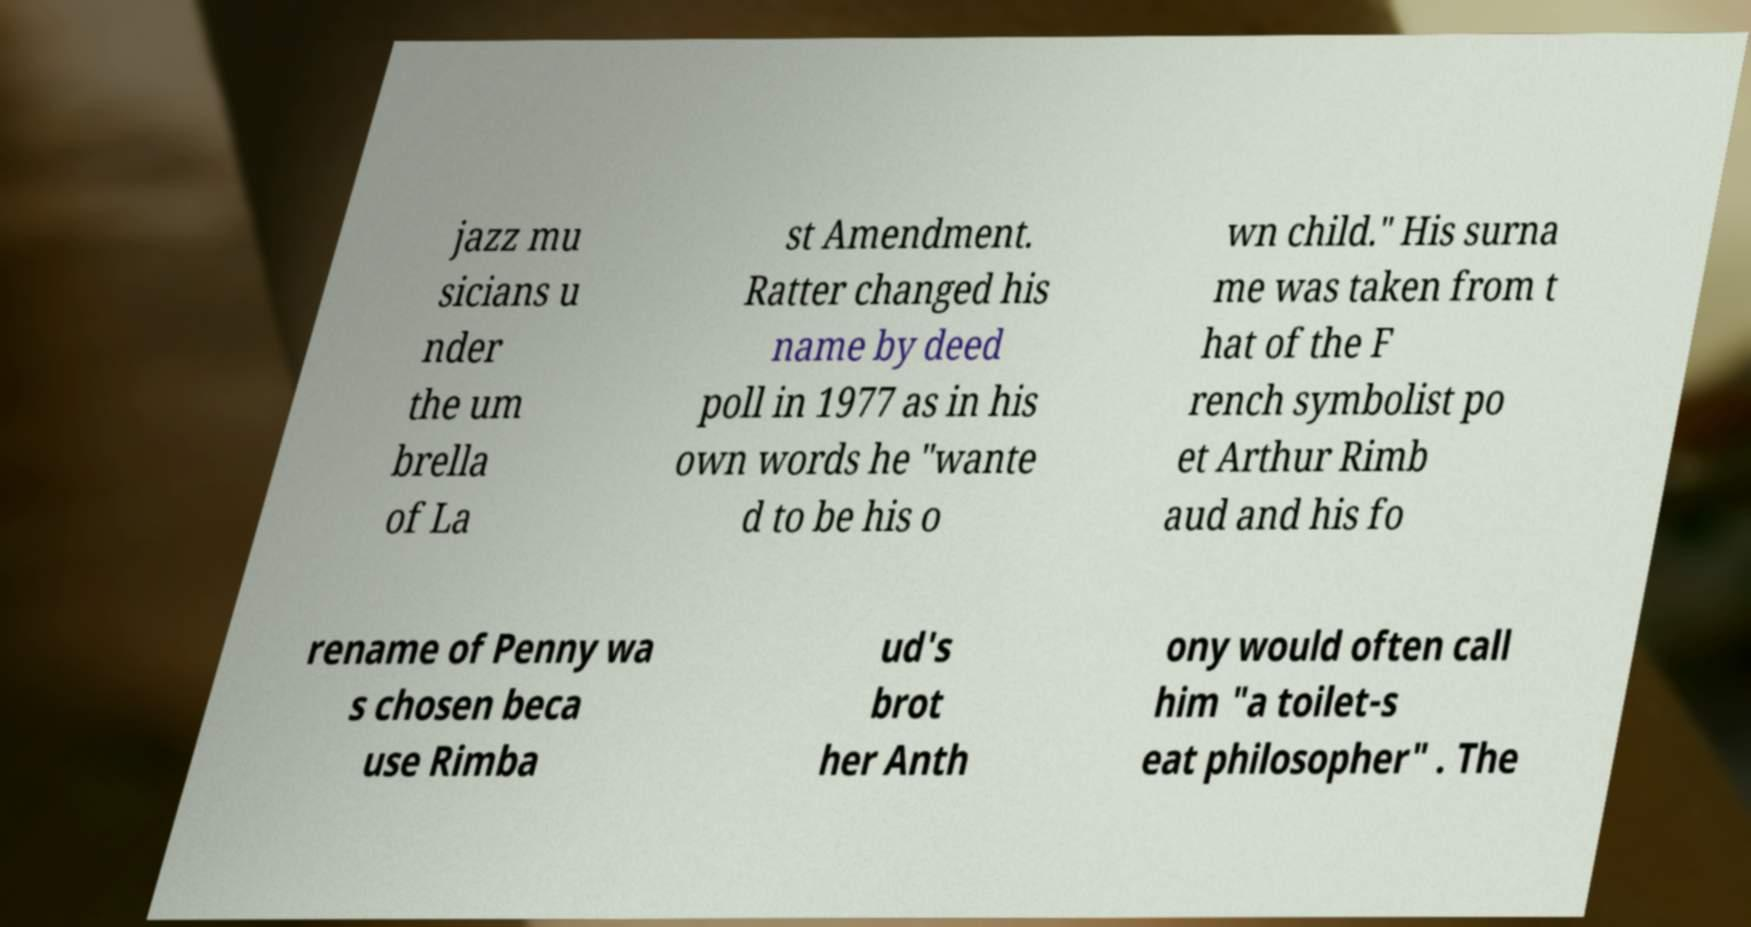Can you read and provide the text displayed in the image?This photo seems to have some interesting text. Can you extract and type it out for me? jazz mu sicians u nder the um brella of La st Amendment. Ratter changed his name by deed poll in 1977 as in his own words he "wante d to be his o wn child." His surna me was taken from t hat of the F rench symbolist po et Arthur Rimb aud and his fo rename of Penny wa s chosen beca use Rimba ud's brot her Anth ony would often call him "a toilet-s eat philosopher" . The 